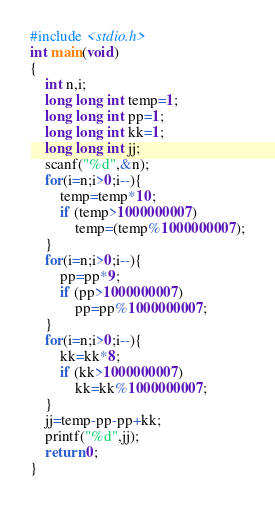Convert code to text. <code><loc_0><loc_0><loc_500><loc_500><_C_>#include <stdio.h>
int main(void)
{
    int n,i;
    long long int temp=1;
    long long int pp=1;
    long long int kk=1;
    long long int jj;
    scanf("%d",&n);
    for(i=n;i>0;i--){
        temp=temp*10;
        if (temp>1000000007)
            temp=(temp%1000000007);
    }
    for(i=n;i>0;i--){
        pp=pp*9;
        if (pp>1000000007)
            pp=pp%1000000007;
    }
    for(i=n;i>0;i--){
        kk=kk*8;
        if (kk>1000000007)
            kk=kk%1000000007;
    }
    jj=temp-pp-pp+kk;
    printf("%d",jj);
    return 0;
}</code> 